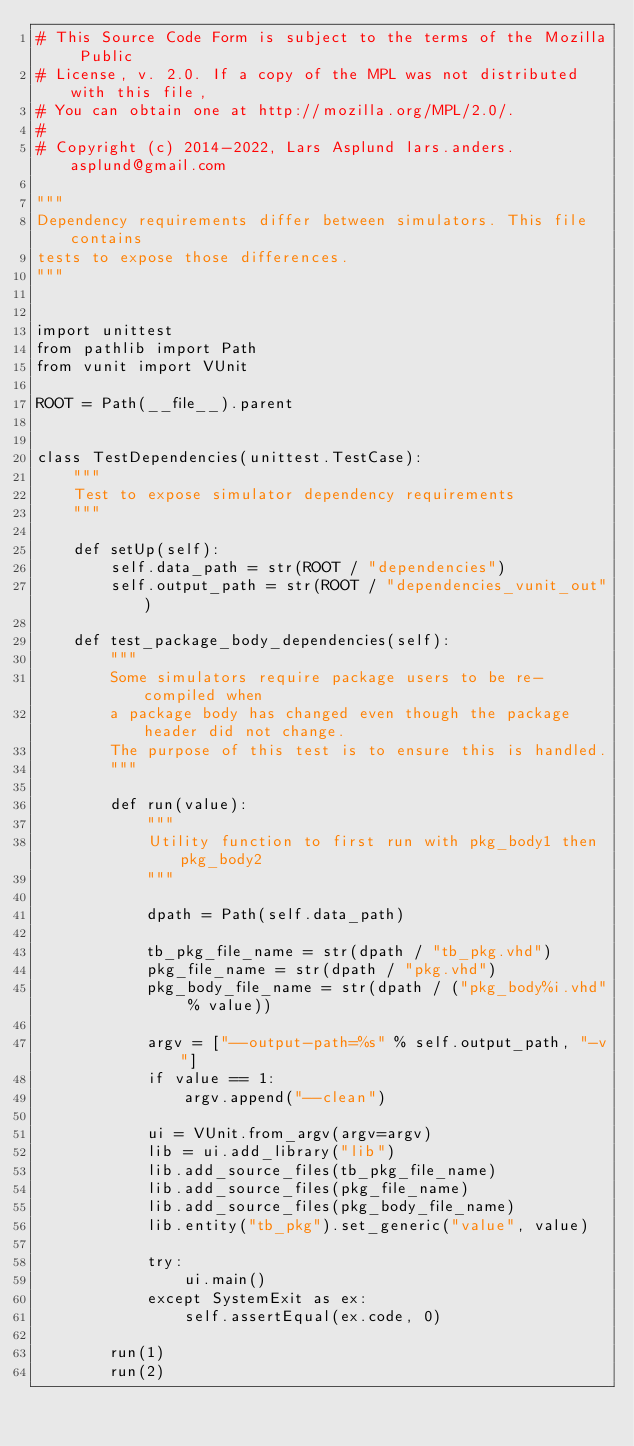<code> <loc_0><loc_0><loc_500><loc_500><_Python_># This Source Code Form is subject to the terms of the Mozilla Public
# License, v. 2.0. If a copy of the MPL was not distributed with this file,
# You can obtain one at http://mozilla.org/MPL/2.0/.
#
# Copyright (c) 2014-2022, Lars Asplund lars.anders.asplund@gmail.com

"""
Dependency requirements differ between simulators. This file contains
tests to expose those differences.
"""


import unittest
from pathlib import Path
from vunit import VUnit

ROOT = Path(__file__).parent


class TestDependencies(unittest.TestCase):
    """
    Test to expose simulator dependency requirements
    """

    def setUp(self):
        self.data_path = str(ROOT / "dependencies")
        self.output_path = str(ROOT / "dependencies_vunit_out")

    def test_package_body_dependencies(self):
        """
        Some simulators require package users to be re-compiled when
        a package body has changed even though the package header did not change.
        The purpose of this test is to ensure this is handled.
        """

        def run(value):
            """
            Utility function to first run with pkg_body1 then pkg_body2
            """

            dpath = Path(self.data_path)

            tb_pkg_file_name = str(dpath / "tb_pkg.vhd")
            pkg_file_name = str(dpath / "pkg.vhd")
            pkg_body_file_name = str(dpath / ("pkg_body%i.vhd" % value))

            argv = ["--output-path=%s" % self.output_path, "-v"]
            if value == 1:
                argv.append("--clean")

            ui = VUnit.from_argv(argv=argv)
            lib = ui.add_library("lib")
            lib.add_source_files(tb_pkg_file_name)
            lib.add_source_files(pkg_file_name)
            lib.add_source_files(pkg_body_file_name)
            lib.entity("tb_pkg").set_generic("value", value)

            try:
                ui.main()
            except SystemExit as ex:
                self.assertEqual(ex.code, 0)

        run(1)
        run(2)
</code> 